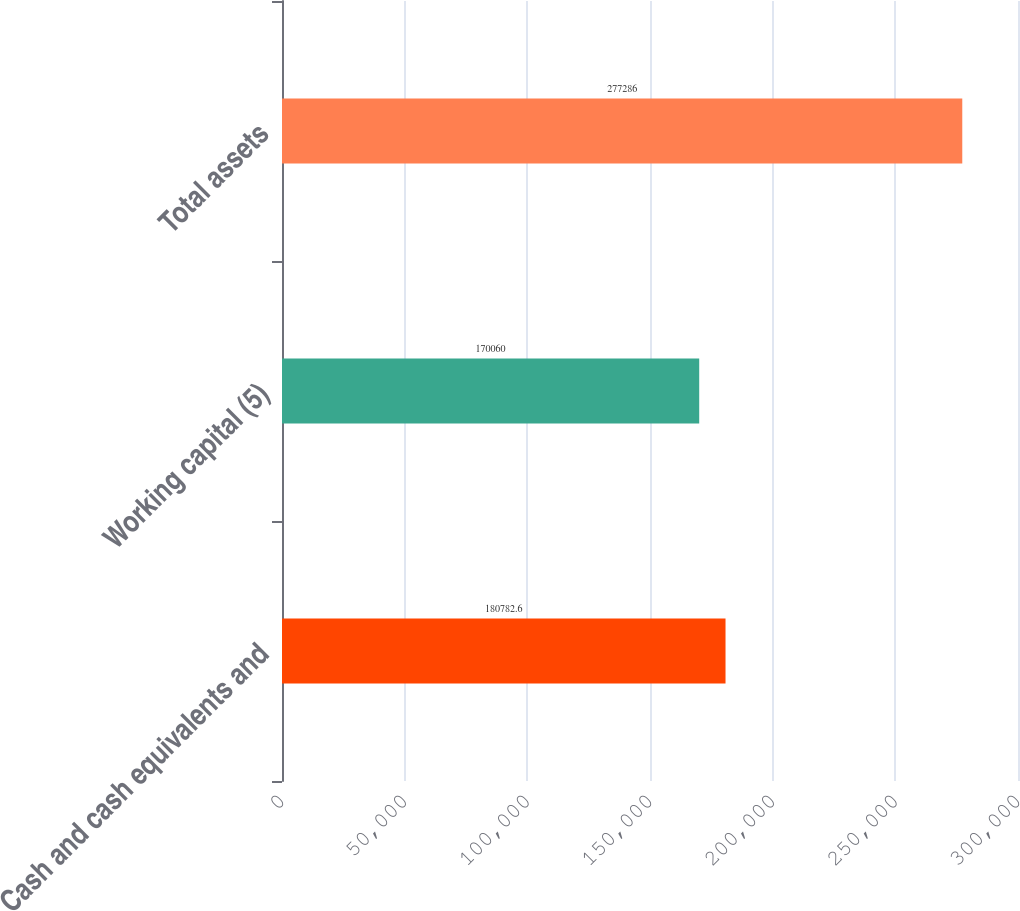Convert chart to OTSL. <chart><loc_0><loc_0><loc_500><loc_500><bar_chart><fcel>Cash and cash equivalents and<fcel>Working capital (5)<fcel>Total assets<nl><fcel>180783<fcel>170060<fcel>277286<nl></chart> 